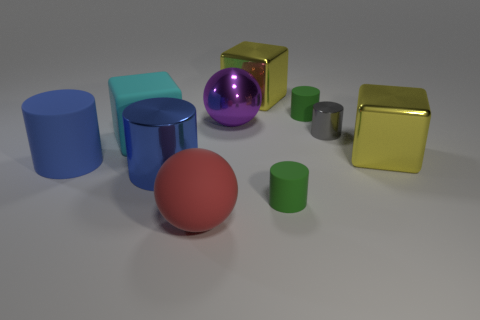Are there any things of the same color as the big metal cylinder?
Make the answer very short. Yes. Do the large shiny cylinder and the big rubber cylinder have the same color?
Provide a succinct answer. Yes. What number of metallic objects are either large objects or purple balls?
Keep it short and to the point. 4. There is a cylinder that is both on the right side of the large purple sphere and in front of the gray metallic object; what color is it?
Your answer should be compact. Green. There is a large blue shiny thing; how many big blue cylinders are to the left of it?
Provide a succinct answer. 1. What is the cyan cube made of?
Give a very brief answer. Rubber. The cylinder that is right of the rubber cylinder that is right of the tiny rubber thing in front of the large purple metallic thing is what color?
Provide a succinct answer. Gray. What number of cyan things have the same size as the purple sphere?
Keep it short and to the point. 1. What is the color of the metallic cylinder that is behind the big blue matte cylinder?
Your answer should be compact. Gray. How many other things are there of the same size as the matte cube?
Give a very brief answer. 6. 